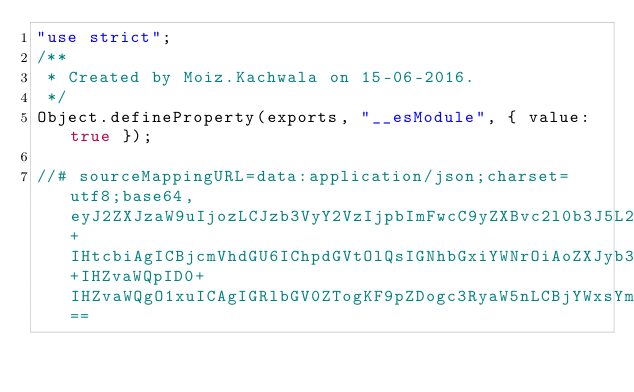Convert code to text. <code><loc_0><loc_0><loc_500><loc_500><_JavaScript_>"use strict";
/**
 * Created by Moiz.Kachwala on 15-06-2016.
 */
Object.defineProperty(exports, "__esModule", { value: true });

//# sourceMappingURL=data:application/json;charset=utf8;base64,eyJ2ZXJzaW9uIjozLCJzb3VyY2VzIjpbImFwcC9yZXBvc2l0b3J5L2ludGVyZmFjZXMvV3JpdGUudHMiXSwibmFtZXMiOltdLCJtYXBwaW5ncyI6IjtBQUFBOztHQUVHIiwiZmlsZSI6ImFwcC9yZXBvc2l0b3J5L2ludGVyZmFjZXMvV3JpdGUuanMiLCJzb3VyY2VzQ29udGVudCI6WyIvKipcbiAqIENyZWF0ZWQgYnkgTW9pei5LYWNod2FsYSBvbiAxNS0wNi0yMDE2LlxuICovXG5cblxuaW1wb3J0IG1vbmdvb3NlID0gcmVxdWlyZShcIm1vbmdvb3NlXCIpO1xuaW50ZXJmYWNlIFdyaXRlPFQ+IHtcbiAgICBjcmVhdGU6IChpdGVtOlQsIGNhbGxiYWNrOiAoZXJyb3I6IGFueSwgcmVzdWx0OiBhbnkgKSA9PiB2b2lkKSA9PiB2b2lkO1xuICAgIHVwZGF0ZTooX2lkOiBtb25nb29zZS5UeXBlcy5PYmplY3RJZCwgaXRlbTpULCBjYWxsYmFjazogKGVycm9yOiBhbnksIHJlc3VsdDogYW55KT0+IHZvaWQpID0+IHZvaWQgO1xuICAgIGRlbGV0ZTogKF9pZDogc3RyaW5nLCBjYWxsYmFjazogKGVycm9yOiBhbnksIHJlc3VsdDogYW55KSA9PiB2b2lkKSA9PiB2b2lkO1xuXG59XG5cbmV4cG9ydCA9IFdyaXRlOyJdfQ==
</code> 